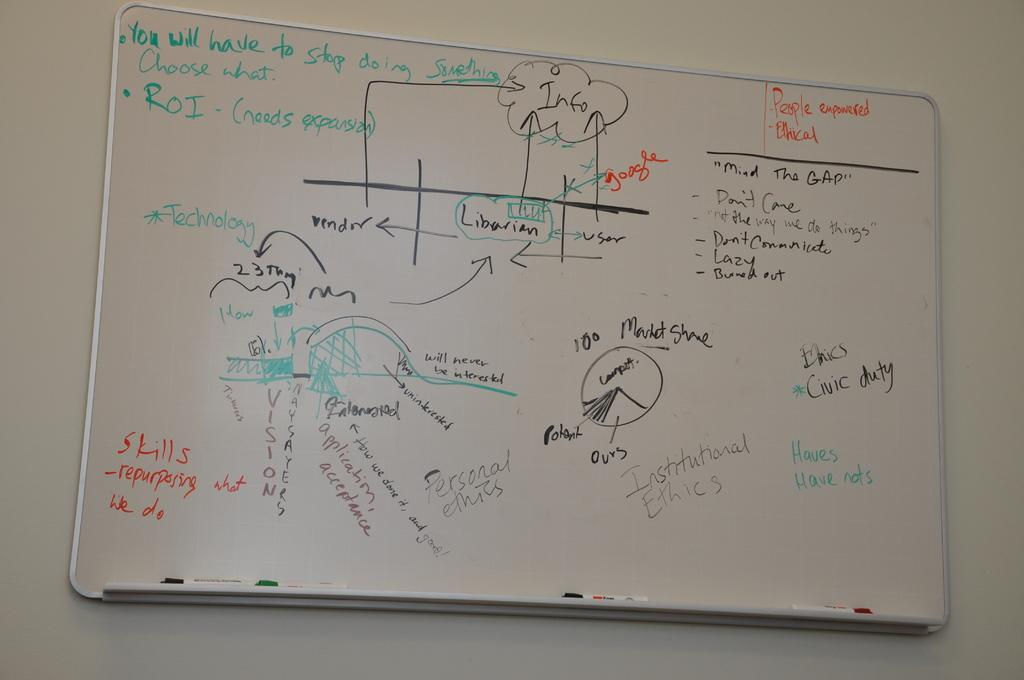<image>
Create a compact narrative representing the image presented. White board in a room with the words People empowered in red. 